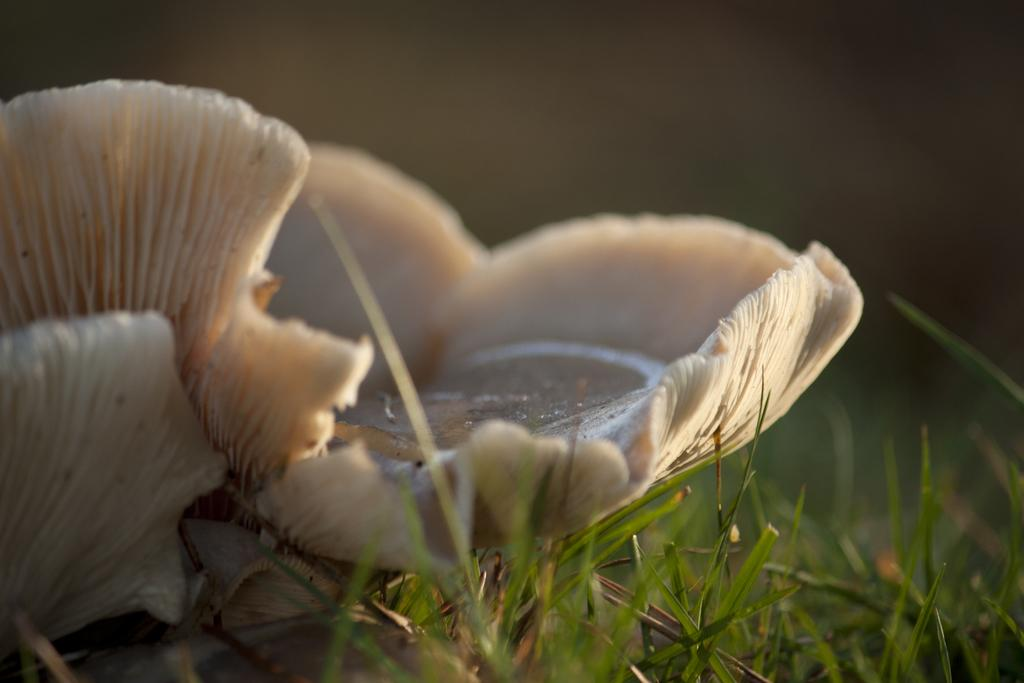What is the color of the object in the image? The object in the image is white. What type of vegetation can be seen in the image? There is green grass in the image. How would you describe the background of the image? The background of the image is blurred. What is the price of the suit in the image? There is no suit present in the image, so it is not possible to determine the price. 